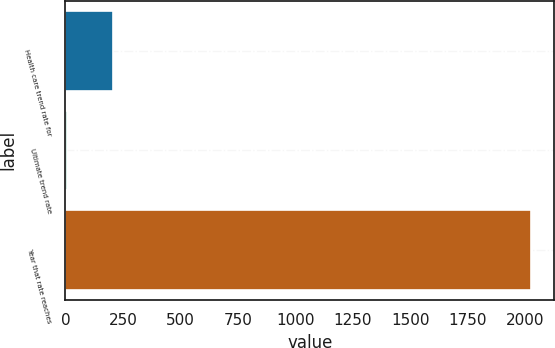Convert chart to OTSL. <chart><loc_0><loc_0><loc_500><loc_500><bar_chart><fcel>Health care trend rate for<fcel>Ultimate trend rate<fcel>Year that rate reaches<nl><fcel>206.8<fcel>5<fcel>2023<nl></chart> 